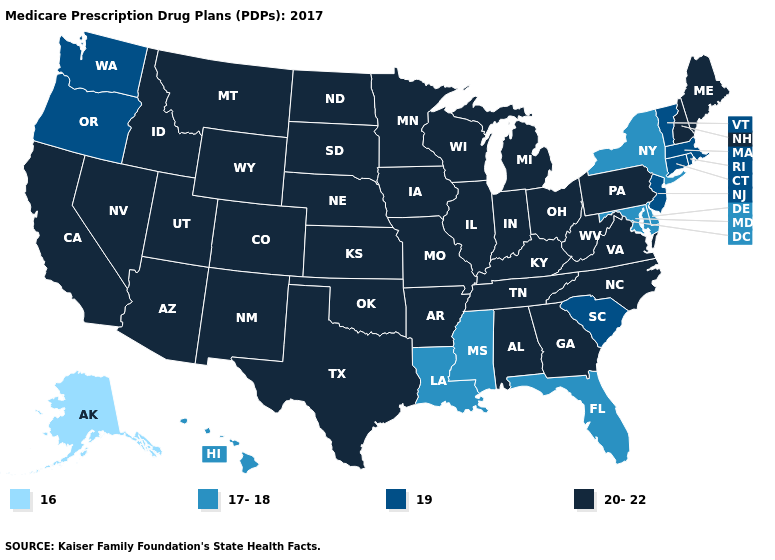Does Tennessee have the same value as Vermont?
Quick response, please. No. What is the lowest value in the USA?
Answer briefly. 16. Which states hav the highest value in the MidWest?
Answer briefly. Iowa, Illinois, Indiana, Kansas, Michigan, Minnesota, Missouri, North Dakota, Nebraska, Ohio, South Dakota, Wisconsin. Which states have the lowest value in the Northeast?
Keep it brief. New York. Does Delaware have the highest value in the South?
Concise answer only. No. What is the value of Illinois?
Write a very short answer. 20-22. Does Louisiana have the same value as Wyoming?
Write a very short answer. No. Which states hav the highest value in the South?
Answer briefly. Alabama, Arkansas, Georgia, Kentucky, North Carolina, Oklahoma, Tennessee, Texas, Virginia, West Virginia. Name the states that have a value in the range 19?
Write a very short answer. Connecticut, Massachusetts, New Jersey, Oregon, Rhode Island, South Carolina, Vermont, Washington. What is the value of Vermont?
Short answer required. 19. What is the highest value in states that border Kentucky?
Be succinct. 20-22. What is the value of Tennessee?
Keep it brief. 20-22. Does the first symbol in the legend represent the smallest category?
Answer briefly. Yes. 